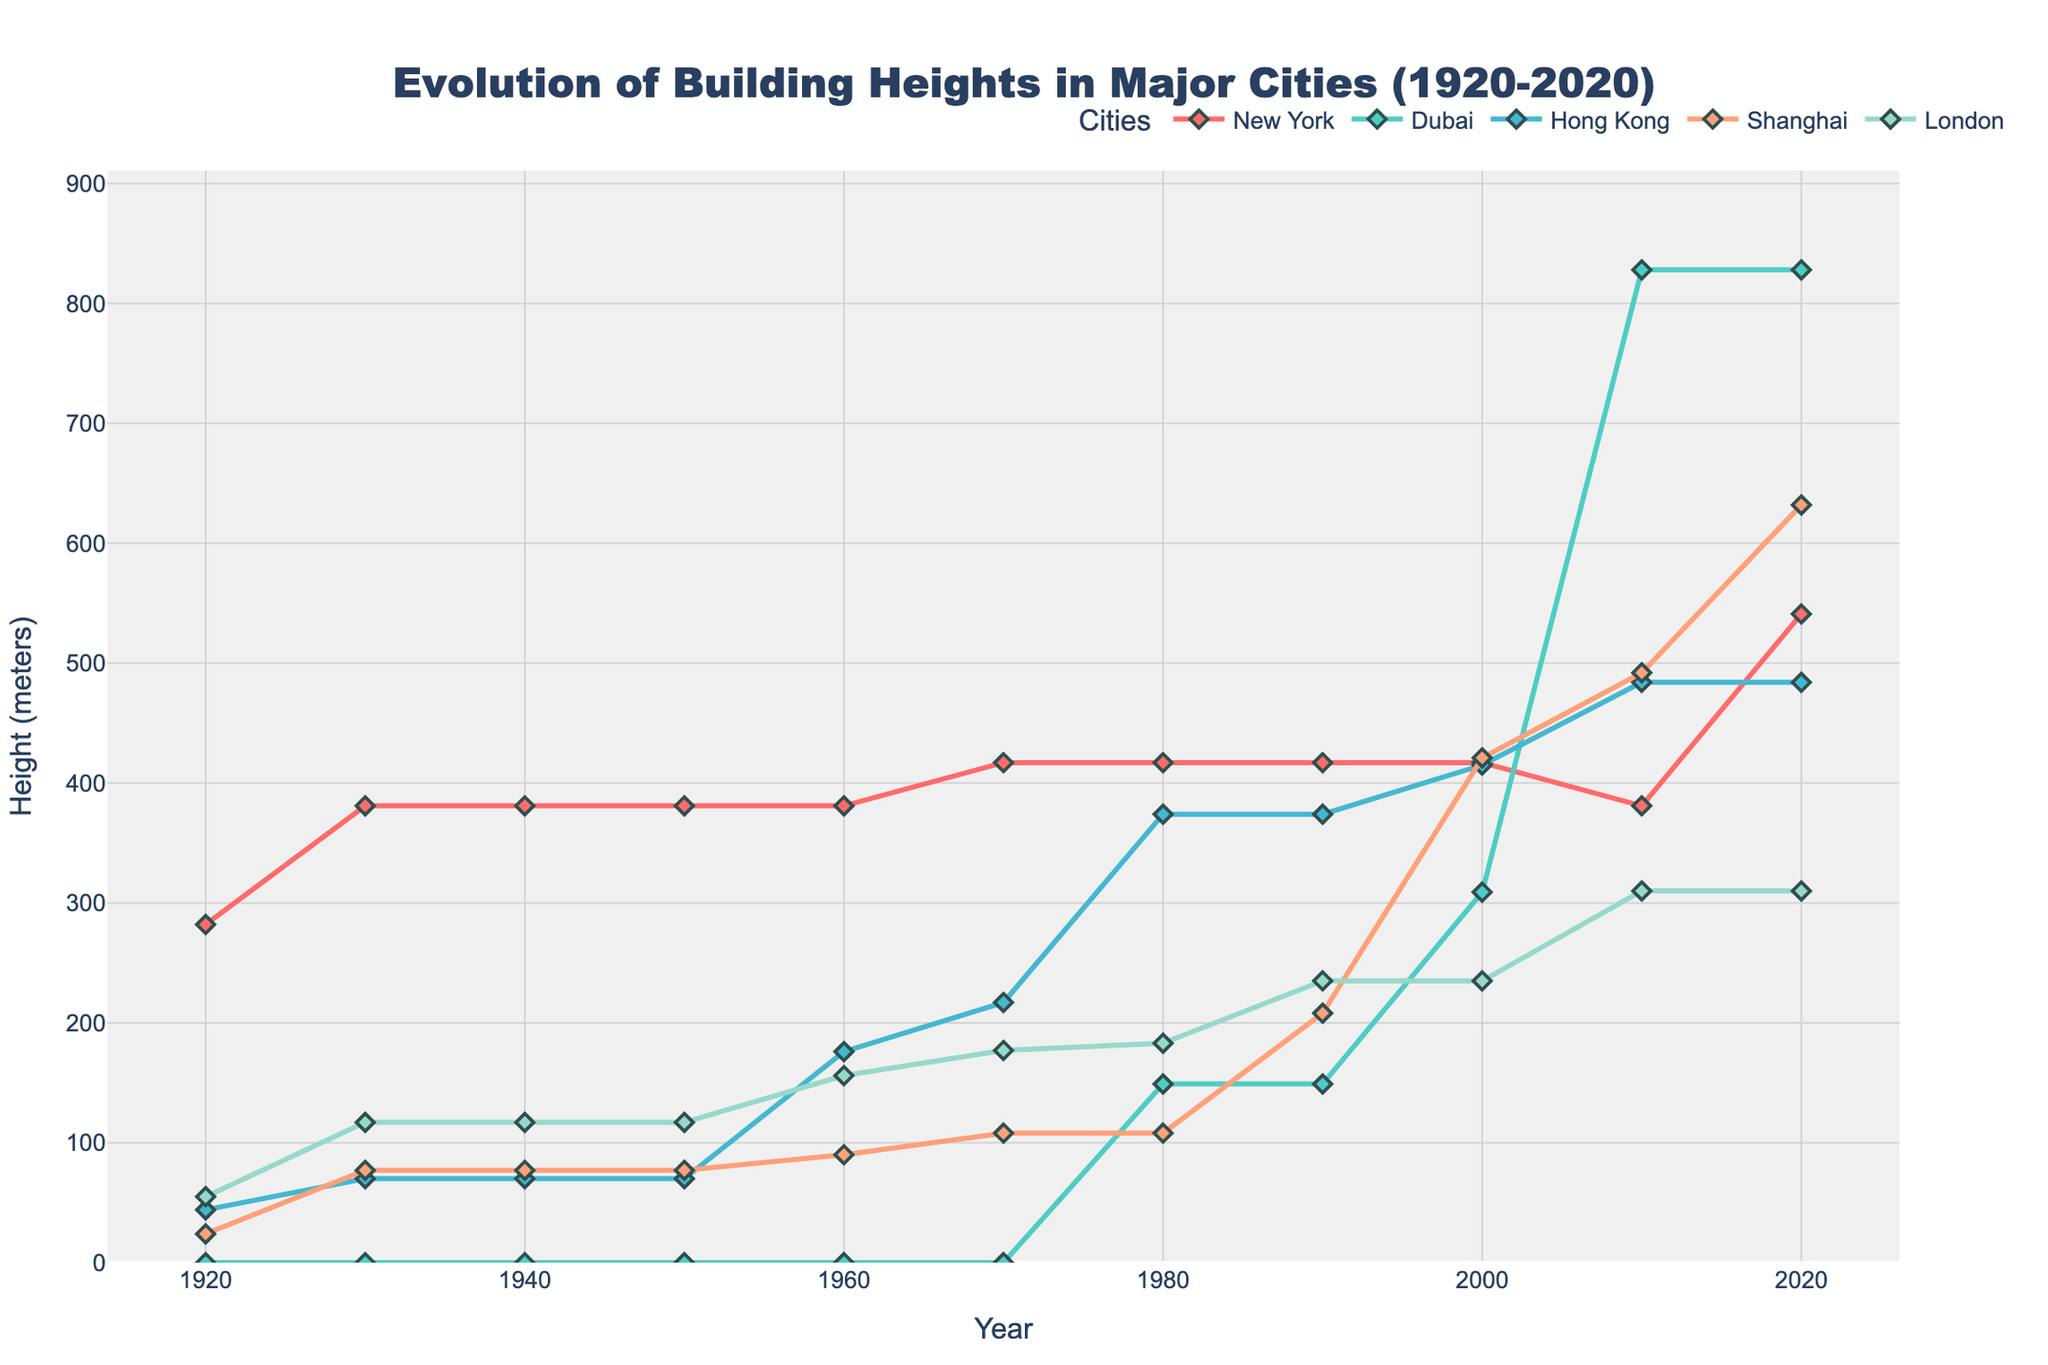What's the tallest building height observed in New York? The tallest building height in New York can be seen at the far right of the red line (New York timeline) in the figure, which is year 2020. This height is 541 meters.
Answer: 541 meters How does the tallest building height in Shanghai in 2020 compare to that of Dubai in the same year? The tallest building height of Shanghai in 2020 is 632 meters and in Dubai it is 828 meters. Comparing these two, Dubai's tallest building is higher than Shanghai's by 196 meters (828 - 632).
Answer: 196 meters Which city showed the most significant change in building height between 2000 and 2010? Between 2000 and 2010, the largest vertical distance on the graph is observed for Dubai, showing a jump from 309 meters to 828 meters.
Answer: Dubai What's the average building height in London in the years 1980, 1990, and 2000? The building heights in London for 1980, 1990, and 2000 are 183 meters, 235 meters, and 235 meters respectively. The sum is (183 + 235 + 235) = 653 meters. The average is 653 / 3 = 217.67 meters.
Answer: 217.67 meters In which decade did New York experience no change in building heights, and what was the height during that period? Examining the New York line on the chart, it remained at 381 meters consistently from 1940 to 1960, which is a period of 20 years covering the 1940s and 1950s.
Answer: 1940s and 1950s; 381 meters Compare the maximum building height reached in Hong Kong to that of London. Which is taller and by how much? The maximum building height for Hong Kong is observed as 484 meters in 2010 and 2020. For London, the maximum height is 310 meters in 2010 and 2020. Thus, Hong Kong's tallest building is 174 meters taller than London's (484 - 310).
Answer: 174 meters What was the increase in building height for Shanghai between 1990 and 2000? The building height for Shanghai in 1990 was 208 meters. In 2000, it was 421 meters. The increase is calculated by 421 - 208 = 213 meters.
Answer: 213 meters Between 1930 and 1950, which city showed the highest rate of change in building height, and what was the specific change? Only New York experienced a change in building heights between 1930 and 1950, with the height changing from 381 meters to 417 meters. Therefore, the rate of change is (417 - 381) = 36 meters over 20 years.
Answer: New York; 36 meters 